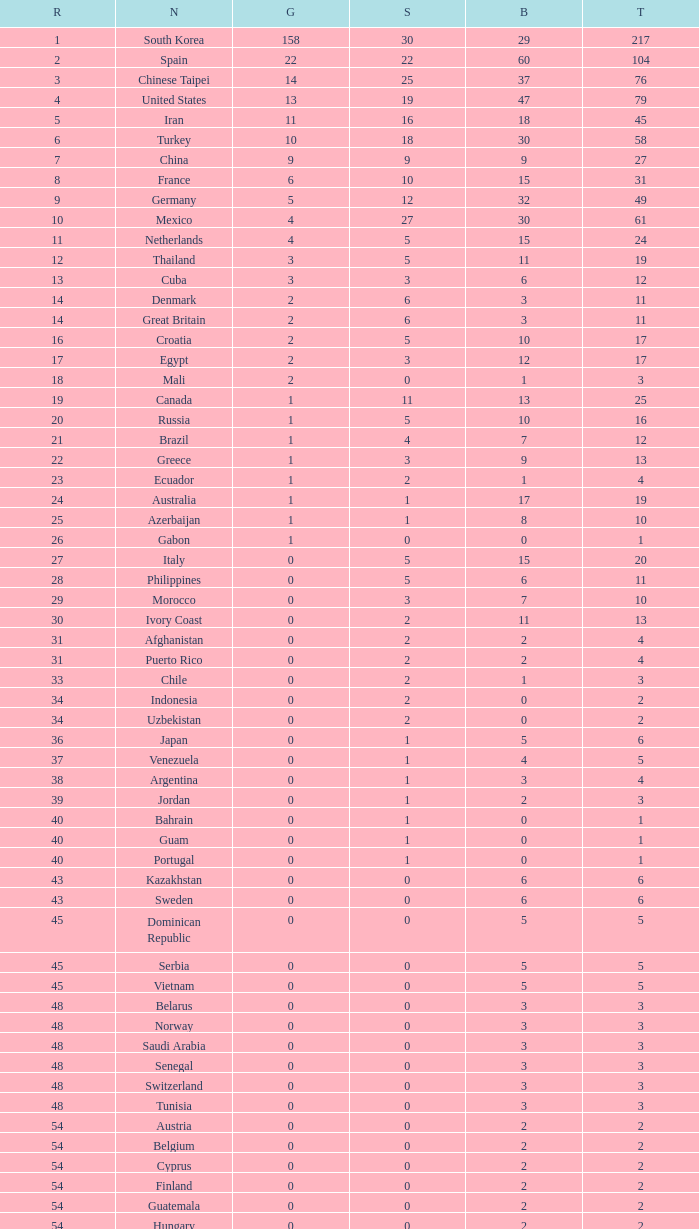What is the Total medals for the Nation ranking 33 with more than 1 Bronze? None. 